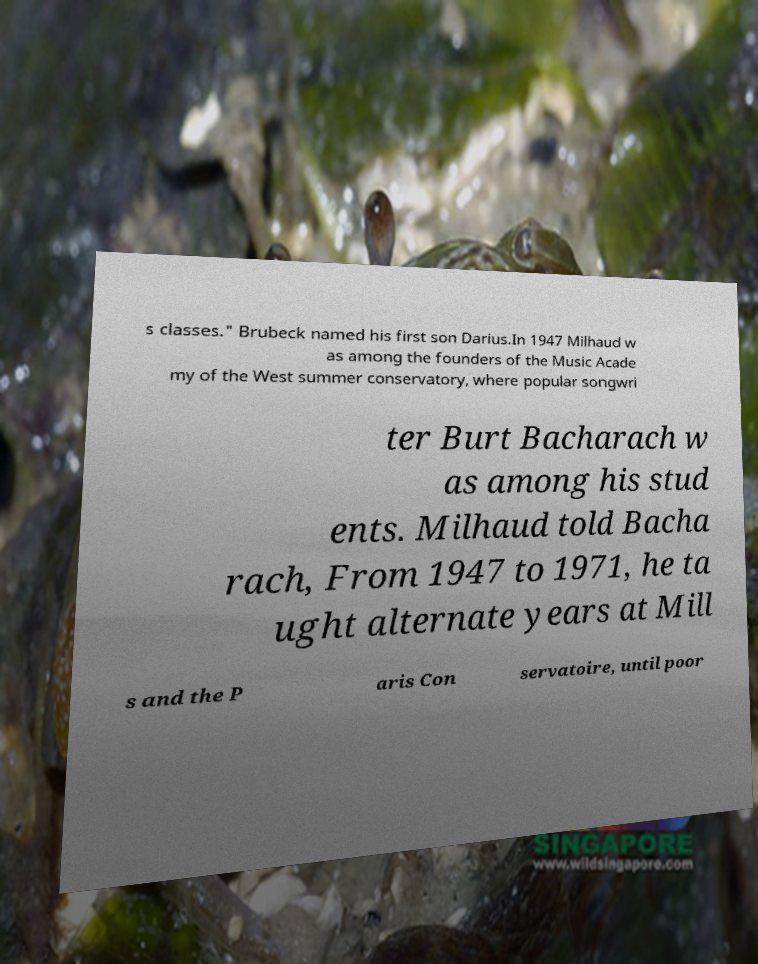Please identify and transcribe the text found in this image. s classes." Brubeck named his first son Darius.In 1947 Milhaud w as among the founders of the Music Acade my of the West summer conservatory, where popular songwri ter Burt Bacharach w as among his stud ents. Milhaud told Bacha rach, From 1947 to 1971, he ta ught alternate years at Mill s and the P aris Con servatoire, until poor 